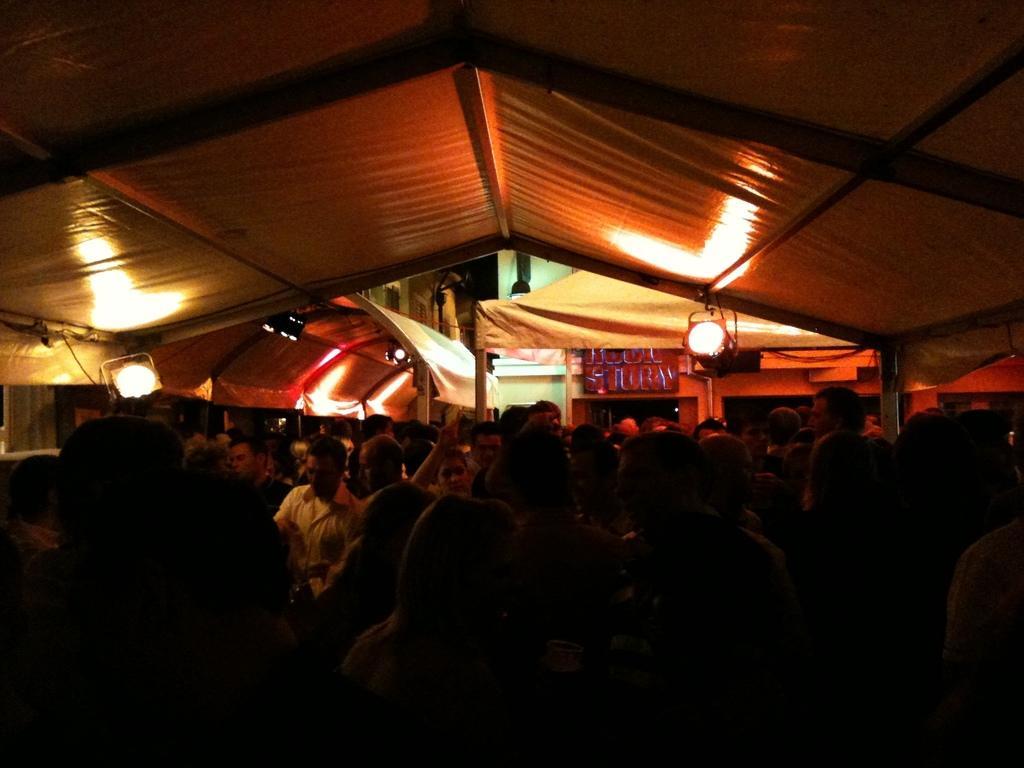Describe this image in one or two sentences. In this image I can see few persons, some are sitting and some are standing, background I can see few tents in white color and I can also see few lights. 